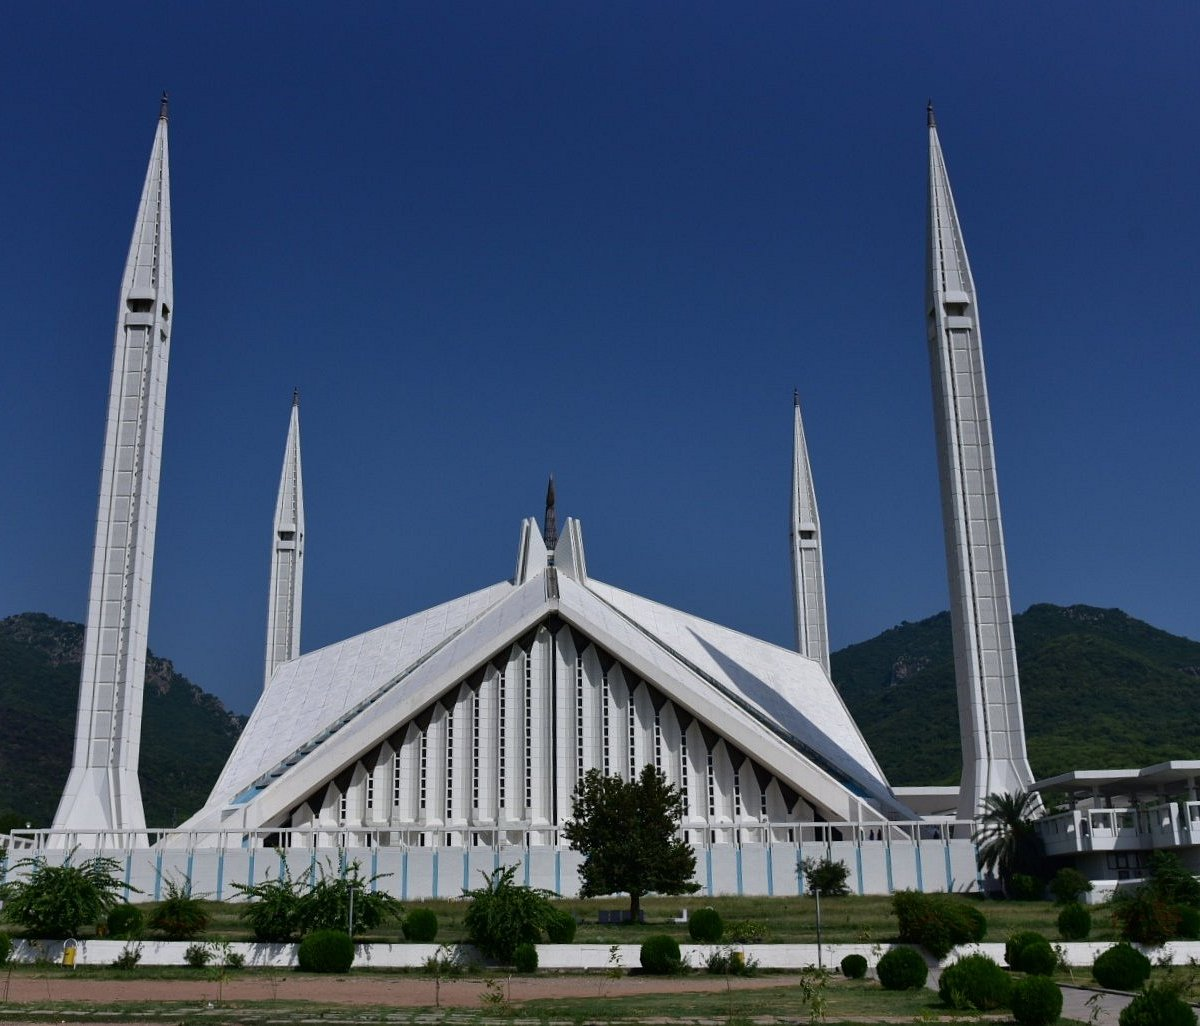What do you think is going on in this snapshot? The image beautifully captures the Faisal Mosque in Islamabad, Pakistan, one of the largest mosques in the world. Known for its contemporary design, which departs from traditional dome structures, it features a striking white marble facade, four sleek minarets standing about 90 meters tall, and a large triangular prayer hall. The mosque is set against the verdant Margalla Hills, offering a picturesque contrast between its brilliant white architecture and the lush green background, symbolizing a blend of modern design and natural serenity. This snapshot not only showcases the mosque’s unique architecture but also highlights it as a serene gathering place for thousands of worshippers, reflecting its importance in the cultural and religious landscape of Pakistan. 